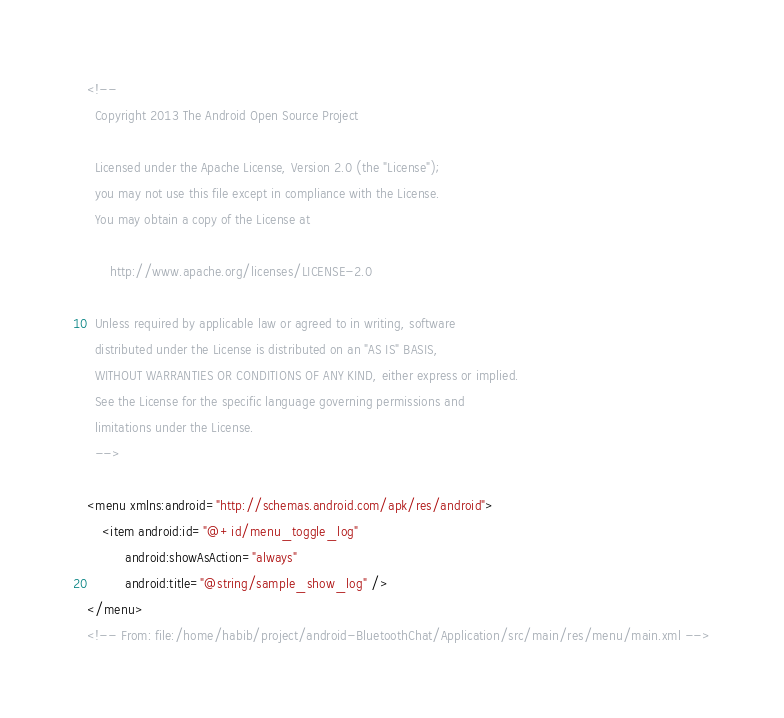<code> <loc_0><loc_0><loc_500><loc_500><_XML_><!--
  Copyright 2013 The Android Open Source Project

  Licensed under the Apache License, Version 2.0 (the "License");
  you may not use this file except in compliance with the License.
  You may obtain a copy of the License at

      http://www.apache.org/licenses/LICENSE-2.0

  Unless required by applicable law or agreed to in writing, software
  distributed under the License is distributed on an "AS IS" BASIS,
  WITHOUT WARRANTIES OR CONDITIONS OF ANY KIND, either express or implied.
  See the License for the specific language governing permissions and
  limitations under the License.
  -->

<menu xmlns:android="http://schemas.android.com/apk/res/android">
    <item android:id="@+id/menu_toggle_log"
          android:showAsAction="always"
          android:title="@string/sample_show_log" />
</menu>
<!-- From: file:/home/habib/project/android-BluetoothChat/Application/src/main/res/menu/main.xml --></code> 